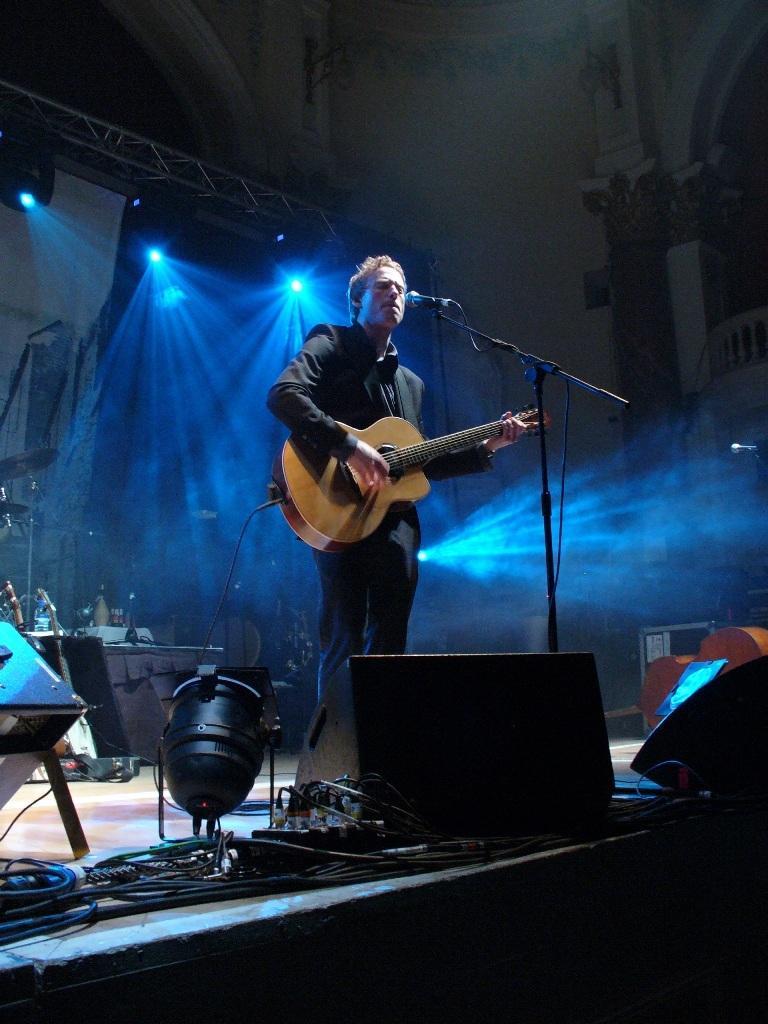Can you describe this image briefly? At the top we can see lights. Here on the platform we can see a man standing in front of a mike and playing guitar. 